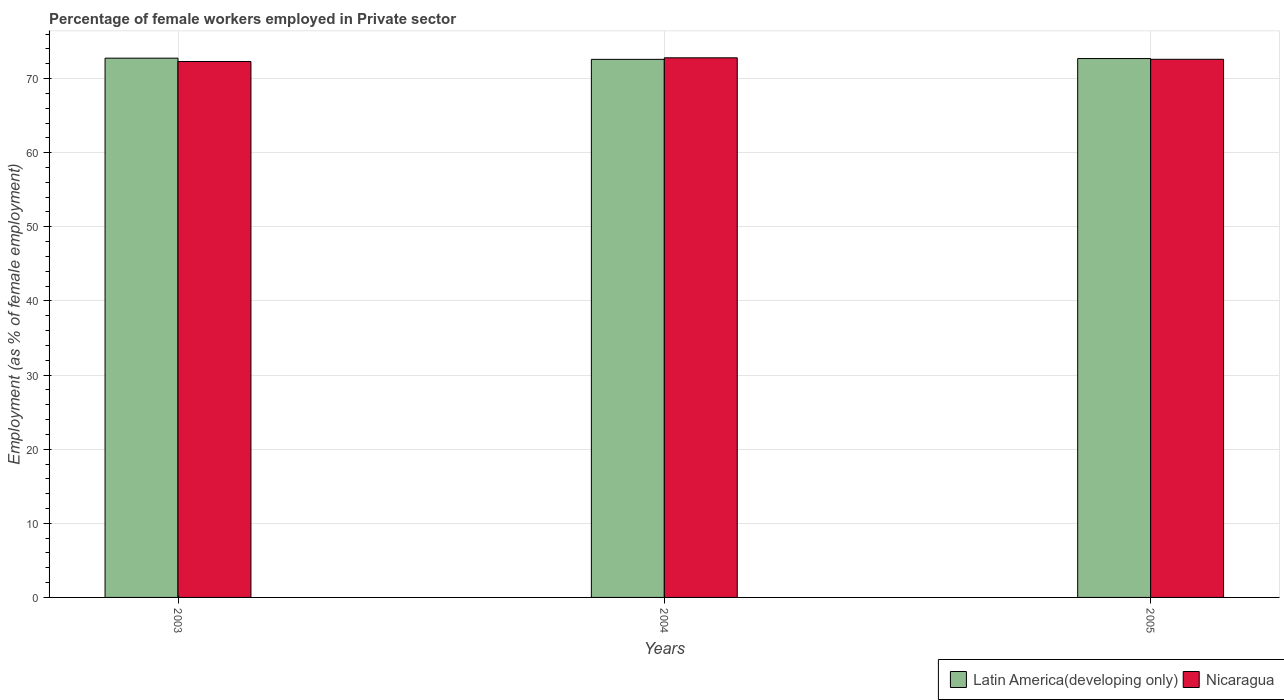How many different coloured bars are there?
Offer a terse response. 2. Are the number of bars per tick equal to the number of legend labels?
Make the answer very short. Yes. How many bars are there on the 2nd tick from the left?
Your answer should be very brief. 2. In how many cases, is the number of bars for a given year not equal to the number of legend labels?
Your answer should be compact. 0. What is the percentage of females employed in Private sector in Latin America(developing only) in 2003?
Your response must be concise. 72.75. Across all years, what is the maximum percentage of females employed in Private sector in Nicaragua?
Offer a terse response. 72.8. Across all years, what is the minimum percentage of females employed in Private sector in Latin America(developing only)?
Keep it short and to the point. 72.59. In which year was the percentage of females employed in Private sector in Nicaragua maximum?
Provide a short and direct response. 2004. In which year was the percentage of females employed in Private sector in Latin America(developing only) minimum?
Your answer should be very brief. 2004. What is the total percentage of females employed in Private sector in Nicaragua in the graph?
Offer a very short reply. 217.7. What is the difference between the percentage of females employed in Private sector in Latin America(developing only) in 2003 and that in 2005?
Your answer should be very brief. 0.05. What is the difference between the percentage of females employed in Private sector in Latin America(developing only) in 2005 and the percentage of females employed in Private sector in Nicaragua in 2004?
Give a very brief answer. -0.1. What is the average percentage of females employed in Private sector in Latin America(developing only) per year?
Offer a terse response. 72.68. In the year 2004, what is the difference between the percentage of females employed in Private sector in Nicaragua and percentage of females employed in Private sector in Latin America(developing only)?
Keep it short and to the point. 0.21. What is the ratio of the percentage of females employed in Private sector in Nicaragua in 2003 to that in 2004?
Give a very brief answer. 0.99. Is the percentage of females employed in Private sector in Nicaragua in 2004 less than that in 2005?
Offer a very short reply. No. What is the difference between the highest and the second highest percentage of females employed in Private sector in Nicaragua?
Your answer should be very brief. 0.2. What is the difference between the highest and the lowest percentage of females employed in Private sector in Latin America(developing only)?
Your answer should be compact. 0.16. In how many years, is the percentage of females employed in Private sector in Nicaragua greater than the average percentage of females employed in Private sector in Nicaragua taken over all years?
Give a very brief answer. 2. Is the sum of the percentage of females employed in Private sector in Latin America(developing only) in 2003 and 2004 greater than the maximum percentage of females employed in Private sector in Nicaragua across all years?
Your answer should be very brief. Yes. What does the 2nd bar from the left in 2005 represents?
Offer a terse response. Nicaragua. What does the 1st bar from the right in 2004 represents?
Your answer should be very brief. Nicaragua. Are all the bars in the graph horizontal?
Make the answer very short. No. Does the graph contain any zero values?
Your answer should be very brief. No. Does the graph contain grids?
Give a very brief answer. Yes. What is the title of the graph?
Keep it short and to the point. Percentage of female workers employed in Private sector. Does "Belize" appear as one of the legend labels in the graph?
Provide a succinct answer. No. What is the label or title of the Y-axis?
Make the answer very short. Employment (as % of female employment). What is the Employment (as % of female employment) in Latin America(developing only) in 2003?
Ensure brevity in your answer.  72.75. What is the Employment (as % of female employment) of Nicaragua in 2003?
Provide a short and direct response. 72.3. What is the Employment (as % of female employment) in Latin America(developing only) in 2004?
Your response must be concise. 72.59. What is the Employment (as % of female employment) in Nicaragua in 2004?
Provide a short and direct response. 72.8. What is the Employment (as % of female employment) of Latin America(developing only) in 2005?
Keep it short and to the point. 72.7. What is the Employment (as % of female employment) of Nicaragua in 2005?
Make the answer very short. 72.6. Across all years, what is the maximum Employment (as % of female employment) of Latin America(developing only)?
Provide a succinct answer. 72.75. Across all years, what is the maximum Employment (as % of female employment) in Nicaragua?
Offer a terse response. 72.8. Across all years, what is the minimum Employment (as % of female employment) of Latin America(developing only)?
Keep it short and to the point. 72.59. Across all years, what is the minimum Employment (as % of female employment) in Nicaragua?
Offer a very short reply. 72.3. What is the total Employment (as % of female employment) in Latin America(developing only) in the graph?
Provide a short and direct response. 218.05. What is the total Employment (as % of female employment) of Nicaragua in the graph?
Your answer should be compact. 217.7. What is the difference between the Employment (as % of female employment) of Latin America(developing only) in 2003 and that in 2004?
Make the answer very short. 0.16. What is the difference between the Employment (as % of female employment) of Latin America(developing only) in 2003 and that in 2005?
Your response must be concise. 0.05. What is the difference between the Employment (as % of female employment) in Nicaragua in 2003 and that in 2005?
Provide a short and direct response. -0.3. What is the difference between the Employment (as % of female employment) in Latin America(developing only) in 2004 and that in 2005?
Offer a very short reply. -0.11. What is the difference between the Employment (as % of female employment) of Nicaragua in 2004 and that in 2005?
Provide a short and direct response. 0.2. What is the difference between the Employment (as % of female employment) in Latin America(developing only) in 2003 and the Employment (as % of female employment) in Nicaragua in 2004?
Offer a terse response. -0.05. What is the difference between the Employment (as % of female employment) of Latin America(developing only) in 2003 and the Employment (as % of female employment) of Nicaragua in 2005?
Give a very brief answer. 0.15. What is the difference between the Employment (as % of female employment) in Latin America(developing only) in 2004 and the Employment (as % of female employment) in Nicaragua in 2005?
Ensure brevity in your answer.  -0.01. What is the average Employment (as % of female employment) of Latin America(developing only) per year?
Provide a short and direct response. 72.68. What is the average Employment (as % of female employment) in Nicaragua per year?
Ensure brevity in your answer.  72.57. In the year 2003, what is the difference between the Employment (as % of female employment) in Latin America(developing only) and Employment (as % of female employment) in Nicaragua?
Ensure brevity in your answer.  0.45. In the year 2004, what is the difference between the Employment (as % of female employment) of Latin America(developing only) and Employment (as % of female employment) of Nicaragua?
Make the answer very short. -0.21. In the year 2005, what is the difference between the Employment (as % of female employment) of Latin America(developing only) and Employment (as % of female employment) of Nicaragua?
Give a very brief answer. 0.1. What is the ratio of the Employment (as % of female employment) in Latin America(developing only) in 2003 to that in 2004?
Keep it short and to the point. 1. What is the ratio of the Employment (as % of female employment) in Latin America(developing only) in 2003 to that in 2005?
Your answer should be compact. 1. What is the ratio of the Employment (as % of female employment) of Nicaragua in 2003 to that in 2005?
Ensure brevity in your answer.  1. What is the ratio of the Employment (as % of female employment) in Nicaragua in 2004 to that in 2005?
Make the answer very short. 1. What is the difference between the highest and the second highest Employment (as % of female employment) of Latin America(developing only)?
Give a very brief answer. 0.05. What is the difference between the highest and the lowest Employment (as % of female employment) in Latin America(developing only)?
Your response must be concise. 0.16. What is the difference between the highest and the lowest Employment (as % of female employment) in Nicaragua?
Ensure brevity in your answer.  0.5. 